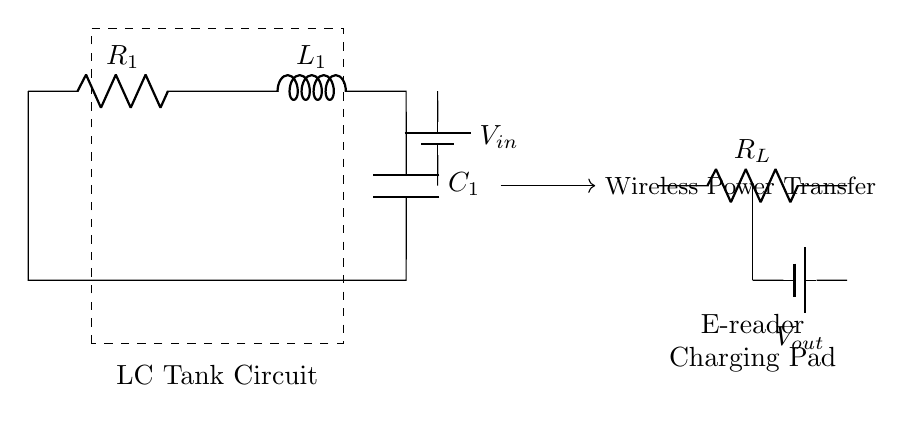What type of circuit is shown in the diagram? The circuit shown is an LC tank circuit, which consists of an inductor and a capacitor connected in parallel or series with a resistor, used for tuning and energy storage.
Answer: LC tank circuit What is the role of the inductor in this circuit? The inductor in this circuit serves to store energy in a magnetic field when current flows through it, and it supports oscillations in conjunction with the capacitor.
Answer: Energy storage What is the voltage supplied to the circuit? The voltage \( V_{in} \) is indicated as the input voltage from the battery connected to the circuit; its specific value isn't defined in this diagram but should be noted wherever relevant.
Answer: V in What is the load resistance labeled in the circuit? The load resistance is labeled \( R_L \) in the circuit diagram, and it represents the resistance that the charging pad will be powering.
Answer: R L How does the LC tank circuit contribute to wireless power transfer? The LC tank circuit enables resonance at a specific frequency, enhancing the efficiency of wireless power transfer by allowing maximum energy transfer between the transmitter and the receiver.
Answer: Resonance What components are part of the LC tank circuit? The components in this LC tank circuit are a resistor, an inductor, and a capacitor, which work together to create oscillatory behavior.
Answer: Resistor, inductor, capacitor Where can the output voltage be measured in this circuit? The output voltage \( V_{out} \) can be measured across the load resistor \( R_L \) at the charging pad, indicating the voltage delivered to the e-reader.
Answer: Across R L 